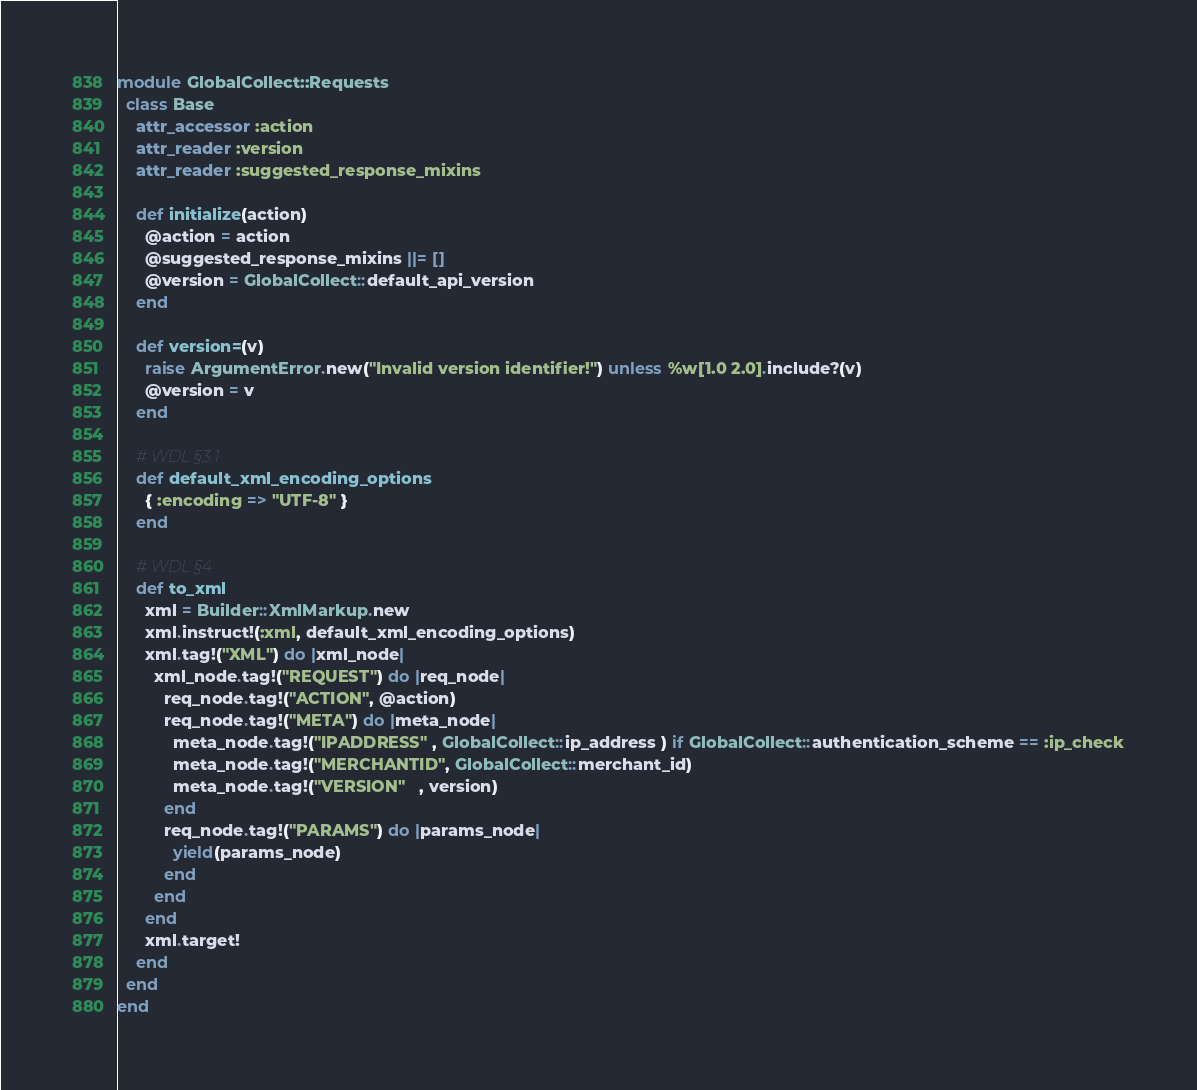<code> <loc_0><loc_0><loc_500><loc_500><_Ruby_>module GlobalCollect::Requests
  class Base
    attr_accessor :action
    attr_reader :version
    attr_reader :suggested_response_mixins
    
    def initialize(action)
      @action = action
      @suggested_response_mixins ||= []
      @version = GlobalCollect::default_api_version
    end
    
    def version=(v)
      raise ArgumentError.new("Invalid version identifier!") unless %w[1.0 2.0].include?(v)
      @version = v
    end
    
    # WDL §3.1
    def default_xml_encoding_options
      { :encoding => "UTF-8" }
    end

    # WDL §4
    def to_xml
      xml = Builder::XmlMarkup.new
      xml.instruct!(:xml, default_xml_encoding_options)
      xml.tag!("XML") do |xml_node|
        xml_node.tag!("REQUEST") do |req_node|
          req_node.tag!("ACTION", @action)
          req_node.tag!("META") do |meta_node|
            meta_node.tag!("IPADDRESS" , GlobalCollect::ip_address ) if GlobalCollect::authentication_scheme == :ip_check
            meta_node.tag!("MERCHANTID", GlobalCollect::merchant_id)
            meta_node.tag!("VERSION"   , version)
          end
          req_node.tag!("PARAMS") do |params_node|
            yield(params_node)
          end
        end
      end
      xml.target!
    end
  end
end
</code> 